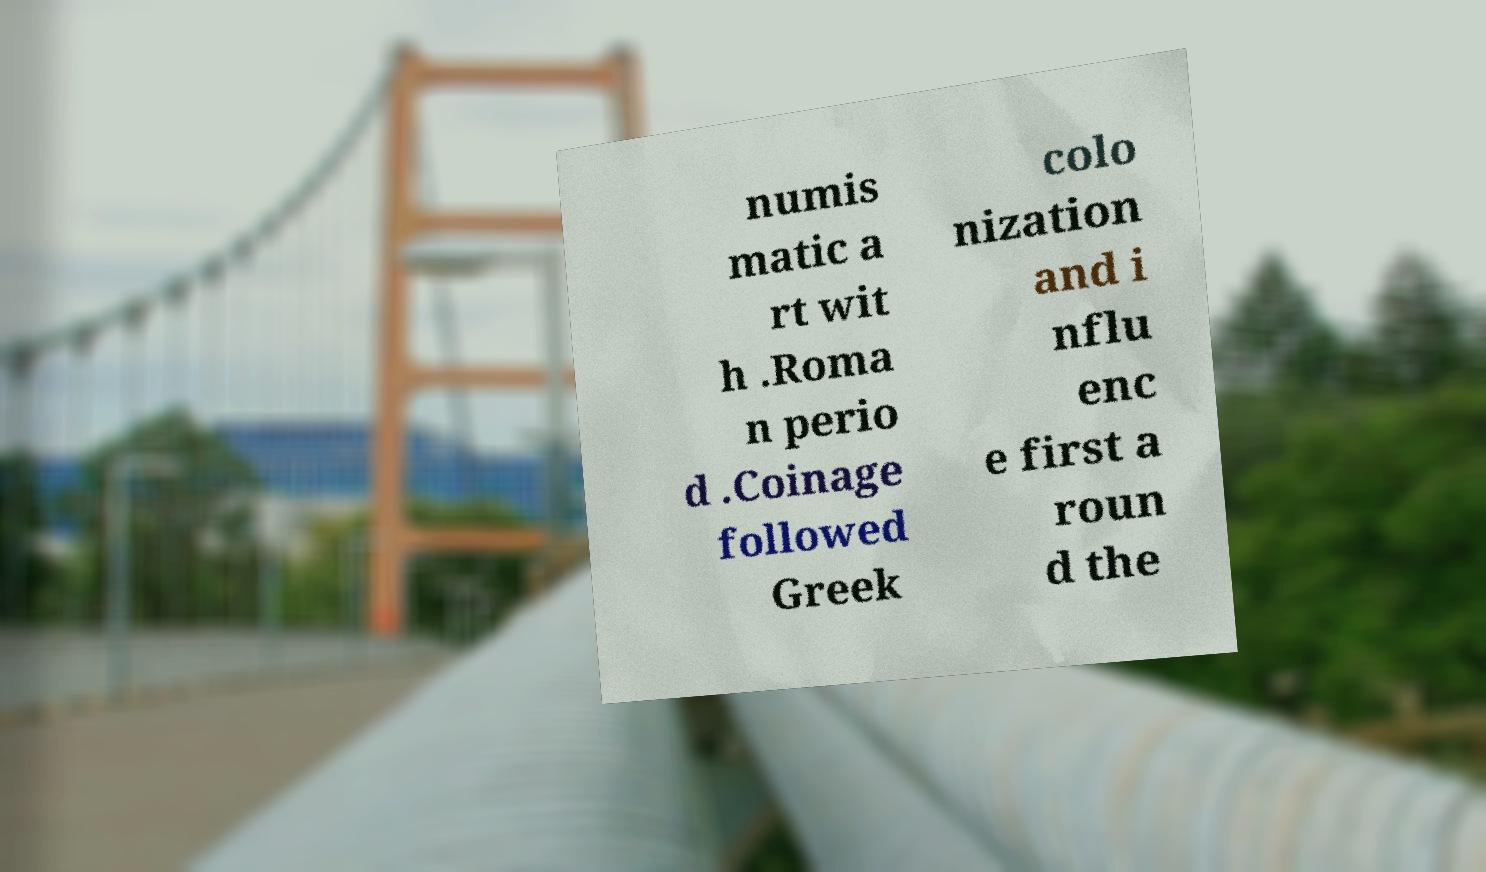Could you assist in decoding the text presented in this image and type it out clearly? numis matic a rt wit h .Roma n perio d .Coinage followed Greek colo nization and i nflu enc e first a roun d the 